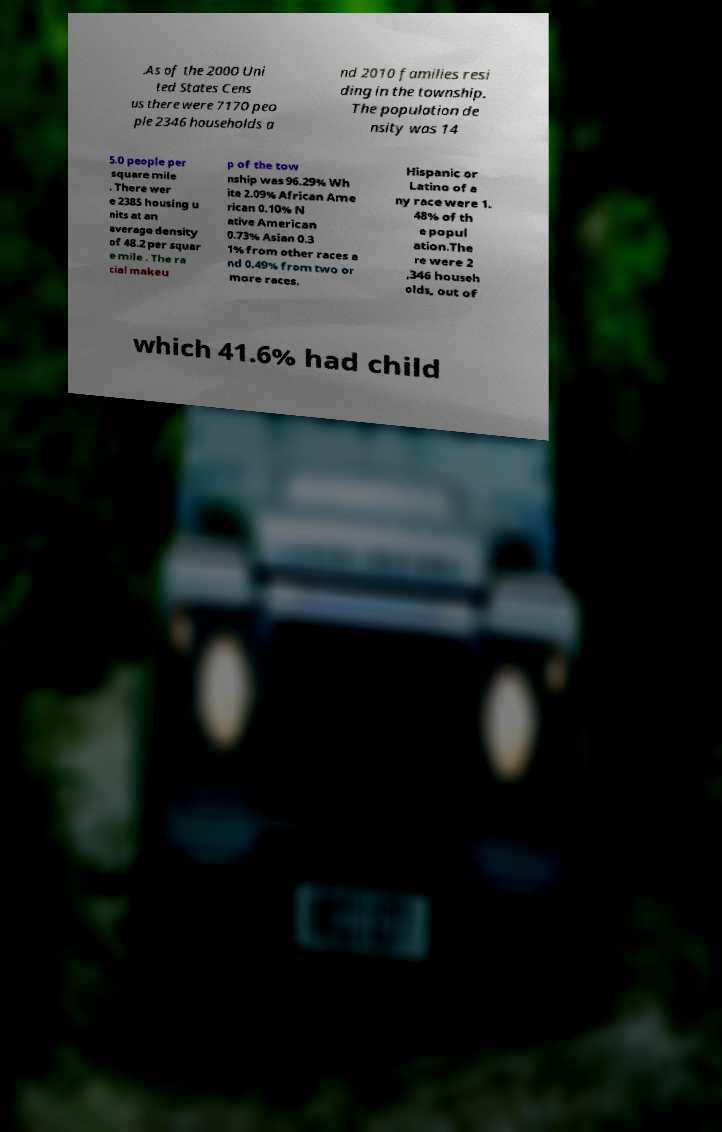Please read and relay the text visible in this image. What does it say? .As of the 2000 Uni ted States Cens us there were 7170 peo ple 2346 households a nd 2010 families resi ding in the township. The population de nsity was 14 5.0 people per square mile . There wer e 2385 housing u nits at an average density of 48.2 per squar e mile . The ra cial makeu p of the tow nship was 96.29% Wh ite 2.09% African Ame rican 0.10% N ative American 0.73% Asian 0.3 1% from other races a nd 0.49% from two or more races. Hispanic or Latino of a ny race were 1. 48% of th e popul ation.The re were 2 ,346 househ olds, out of which 41.6% had child 